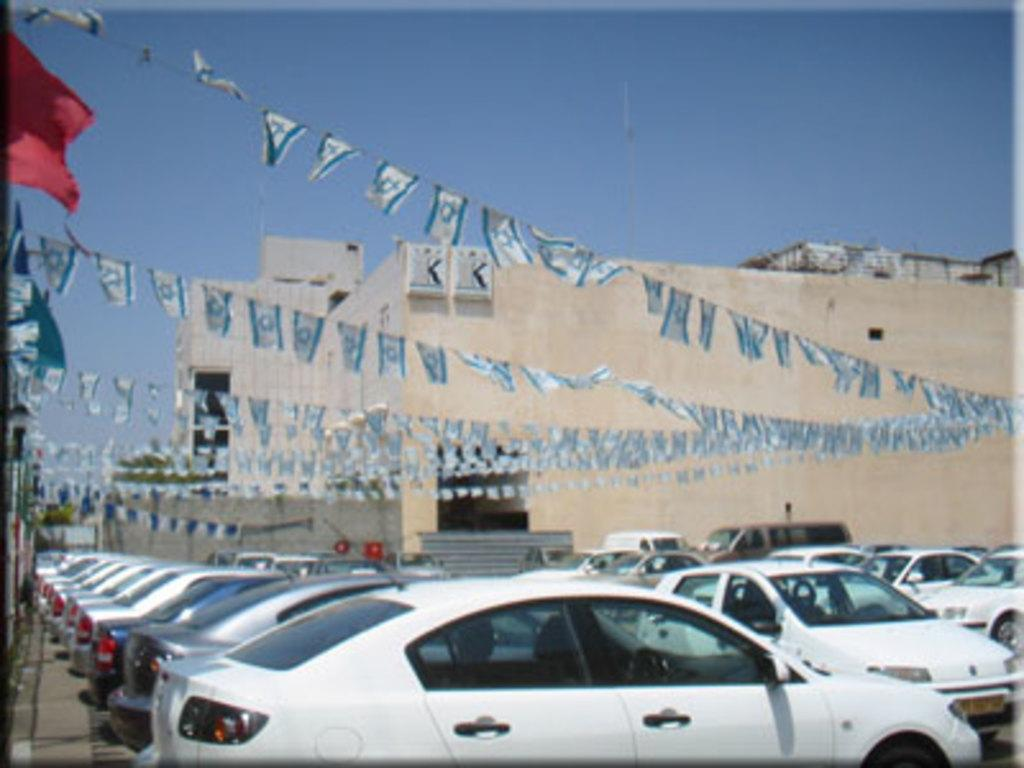What can be seen in the image related to transportation? There are cars parked in the image. Where are the cars located in the image? The cars are parked in an area. What is attached to ropes above the cars? There are flags attached to ropes above the cars. What can be seen in the background of the image? There is a building in the background of the image. What type of book can be seen on the hood of the car in the image? There is no book present on the hood of any car in the image. 